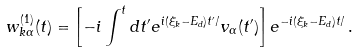Convert formula to latex. <formula><loc_0><loc_0><loc_500><loc_500>w _ { k \alpha } ^ { ( 1 ) } ( t ) = \left [ - i \int ^ { t } d t ^ { \prime } e ^ { i ( \xi _ { k } - E _ { d } ) t ^ { \prime } / } v _ { \alpha } ( t ^ { \prime } ) \right ] e ^ { - i ( \xi _ { k } - E _ { d } ) t / } \, .</formula> 